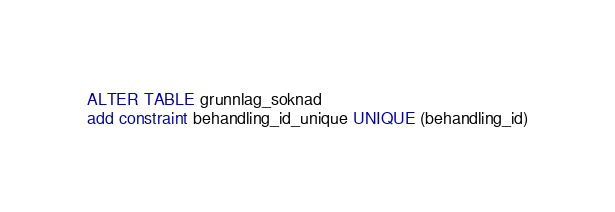Convert code to text. <code><loc_0><loc_0><loc_500><loc_500><_SQL_>ALTER TABLE grunnlag_soknad
add constraint behandling_id_unique UNIQUE (behandling_id)</code> 